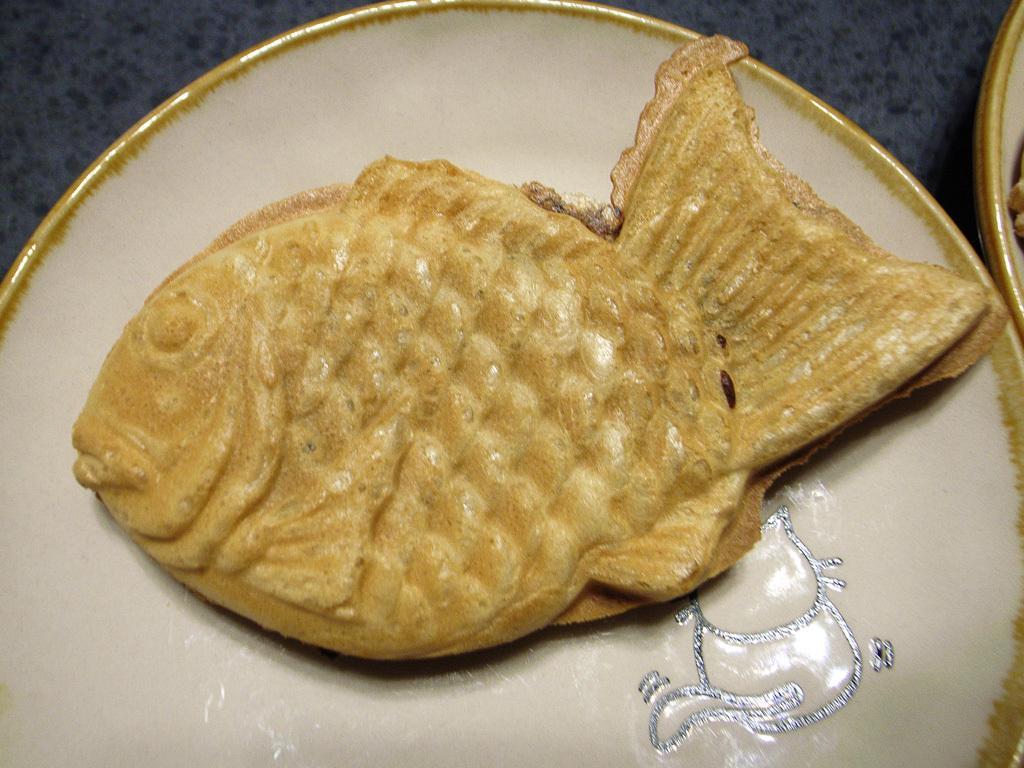How would you summarize this image in a sentence or two? There we can see a food on the white plate. 